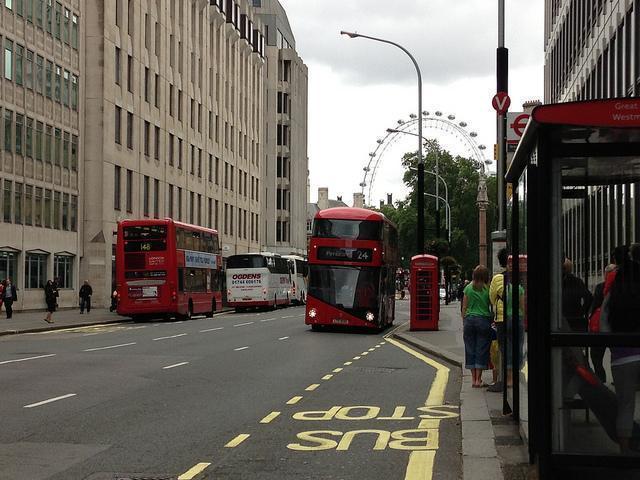What company owns vehicles similar to the ones in the street?
Pick the correct solution from the four options below to address the question.
Options: Tesla, dunkin donuts, mcdonalds, greyhound. Greyhound. 